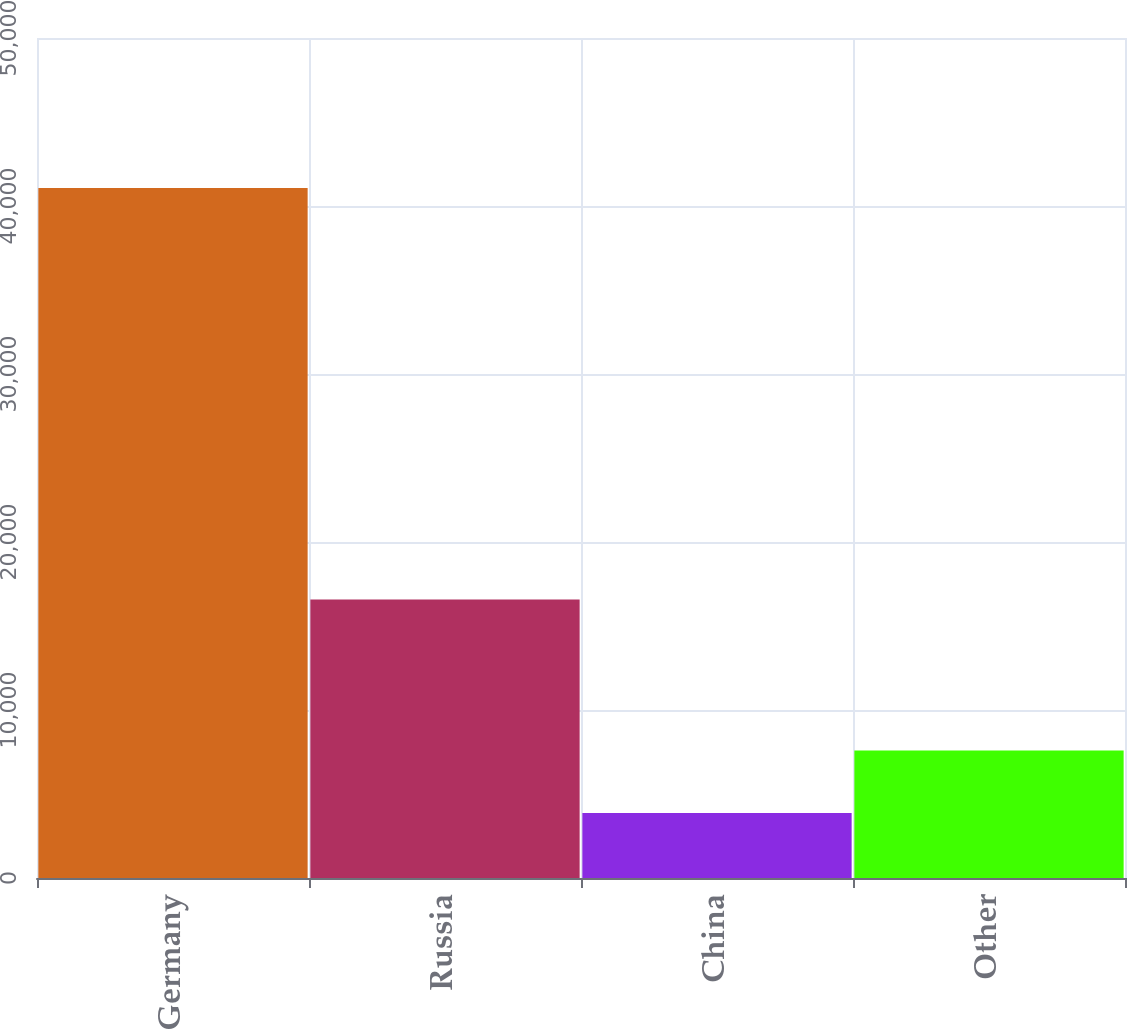<chart> <loc_0><loc_0><loc_500><loc_500><bar_chart><fcel>Germany<fcel>Russia<fcel>China<fcel>Other<nl><fcel>41065<fcel>16578<fcel>3865<fcel>7585<nl></chart> 